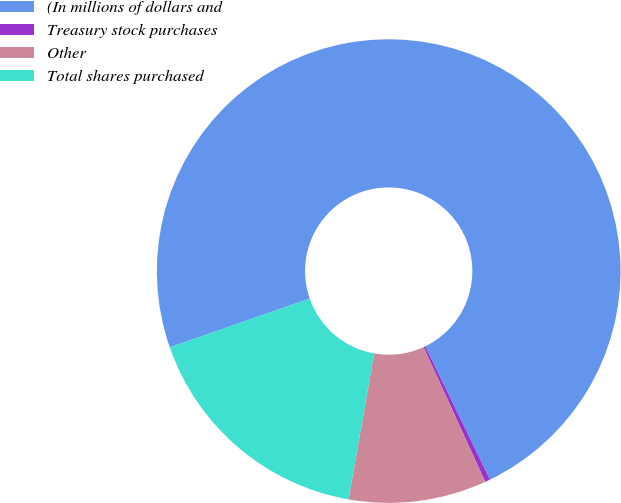Convert chart. <chart><loc_0><loc_0><loc_500><loc_500><pie_chart><fcel>(In millions of dollars and<fcel>Treasury stock purchases<fcel>Other<fcel>Total shares purchased<nl><fcel>73.14%<fcel>0.36%<fcel>9.61%<fcel>16.89%<nl></chart> 